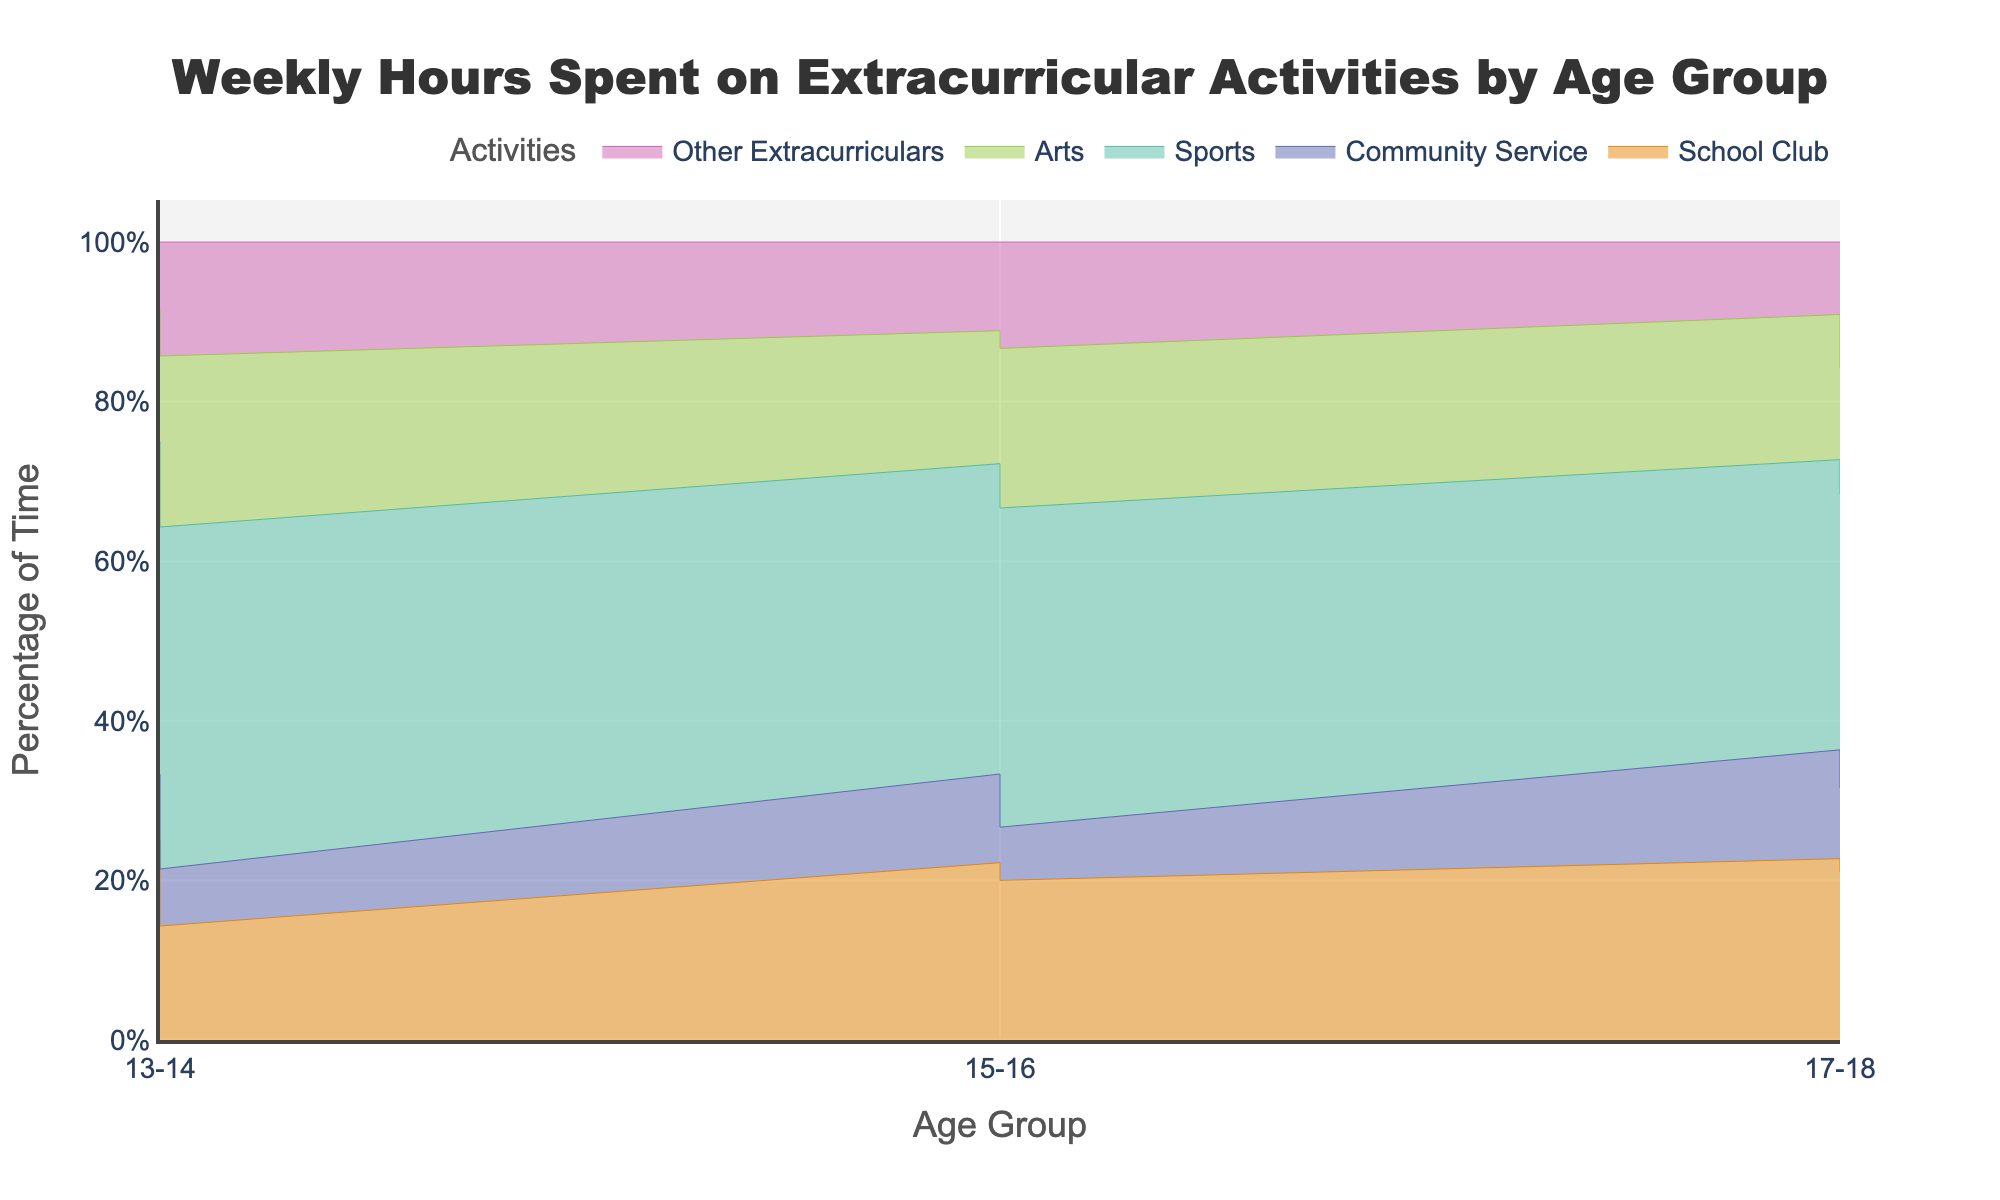What's the title of the chart? The title of the chart is displayed prominently at the top. It reads "Weekly Hours Spent on Extracurricular Activities by Age Group."
Answer: Weekly Hours Spent on Extracurricular Activities by Age Group What age group spends the most time on sports? To answer this, look for which age group has the largest area corresponding to "Sports" in the step area chart. The highest area for "Sports" is seen for the 17-18 age group.
Answer: 17-18 Which activity decreases in percentage as age increases? Examine the different stacks and observe their trends across age groups. "Community Service" decreases as age increases.
Answer: Community Service How does the percentage of time spent on "Arts" change from age group 13-14 to 17-18? Identify the areas representing "Arts" for both age groups and note the heights of these areas. "Arts" increases from the 13-14 age group to the 17-18 age group.
Answer: Increases Compare the total time spent on "School Club" and "Other Extracurriculars" for the 15-16 age group. Which one is higher? Observe the areas for "School Club" and "Other Extracurriculars" for the 15-16 age group. "School Club" has a larger area than "Other Extracurriculars."
Answer: School Club What is the total percentage of time spent on "Sports" and "Arts" for the 17-18 age group? Look at the heights of the "Sports" and "Arts" areas for the 17-18 age group and add them. "Sports" is around 8%, and "Arts" is about 4%, giving a total of 12%.
Answer: 12% Which activity shows the most consistent percentage across all age groups? Look at all the activities and see which one has a similar height across all age groups. "Other Extracurriculars" seems to be the most consistent.
Answer: Other Extracurriculars What's the difference in the time percentage spent on "Sports" between the 15-16 and 17-18 age groups? Compare the areas representing "Sports" for both age groups and note the difference. "Sports" is around 6% for 15-16 and 8% for 17-18, so the difference is 2%.
Answer: 2% Which age group spends the least time on "Community Service"? Find the area corresponding to "Community Service" across all age groups. The lowest area for "Community Service" is observed for the 13-14 age group.
Answer: 13-14 How does the overall pattern of extracurricular activities differ among age groups? Look for trends and differences in the heights and shapes of the areas for each activity. Generally, older age groups tend to spend more time on sports and arts, with a reduction in community service.
Answer: Older groups spend more on sports and arts, less on community service 